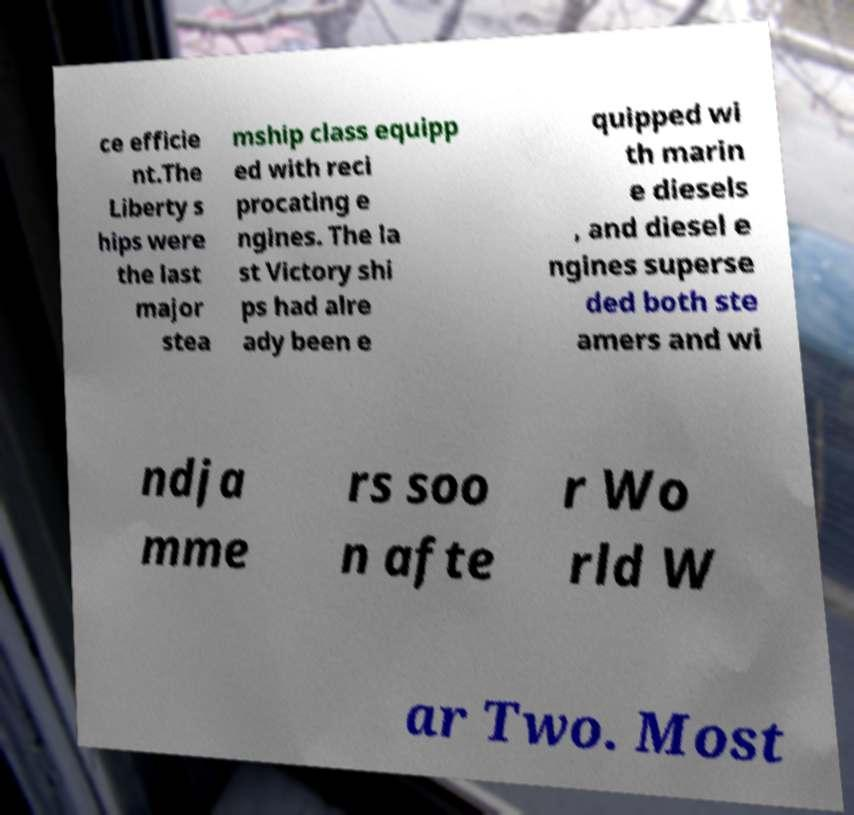What messages or text are displayed in this image? I need them in a readable, typed format. ce efficie nt.The Liberty s hips were the last major stea mship class equipp ed with reci procating e ngines. The la st Victory shi ps had alre ady been e quipped wi th marin e diesels , and diesel e ngines superse ded both ste amers and wi ndja mme rs soo n afte r Wo rld W ar Two. Most 